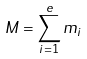<formula> <loc_0><loc_0><loc_500><loc_500>M = \sum _ { i = 1 } ^ { e } m _ { i }</formula> 